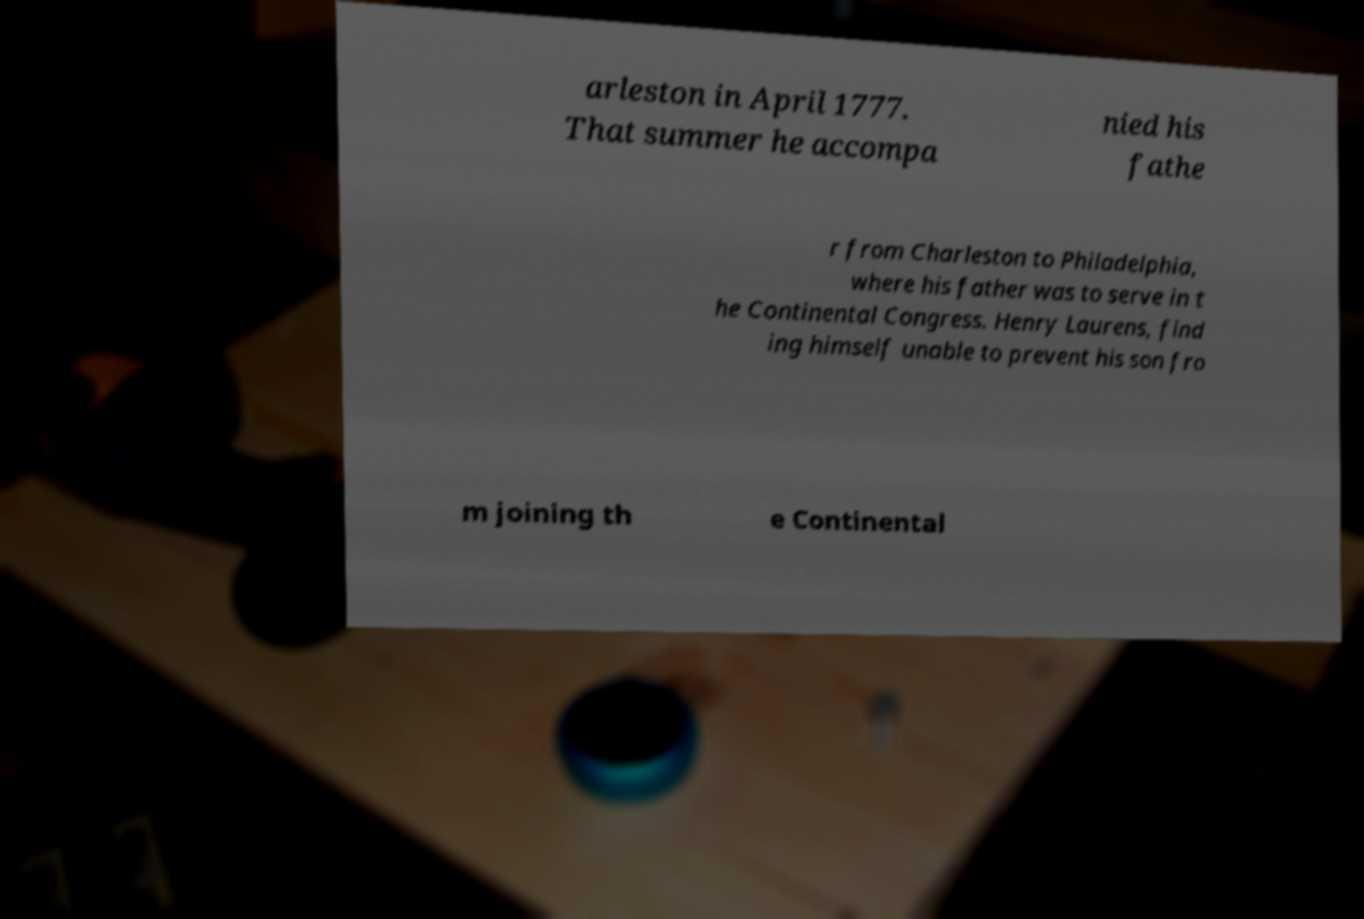Please read and relay the text visible in this image. What does it say? arleston in April 1777. That summer he accompa nied his fathe r from Charleston to Philadelphia, where his father was to serve in t he Continental Congress. Henry Laurens, find ing himself unable to prevent his son fro m joining th e Continental 